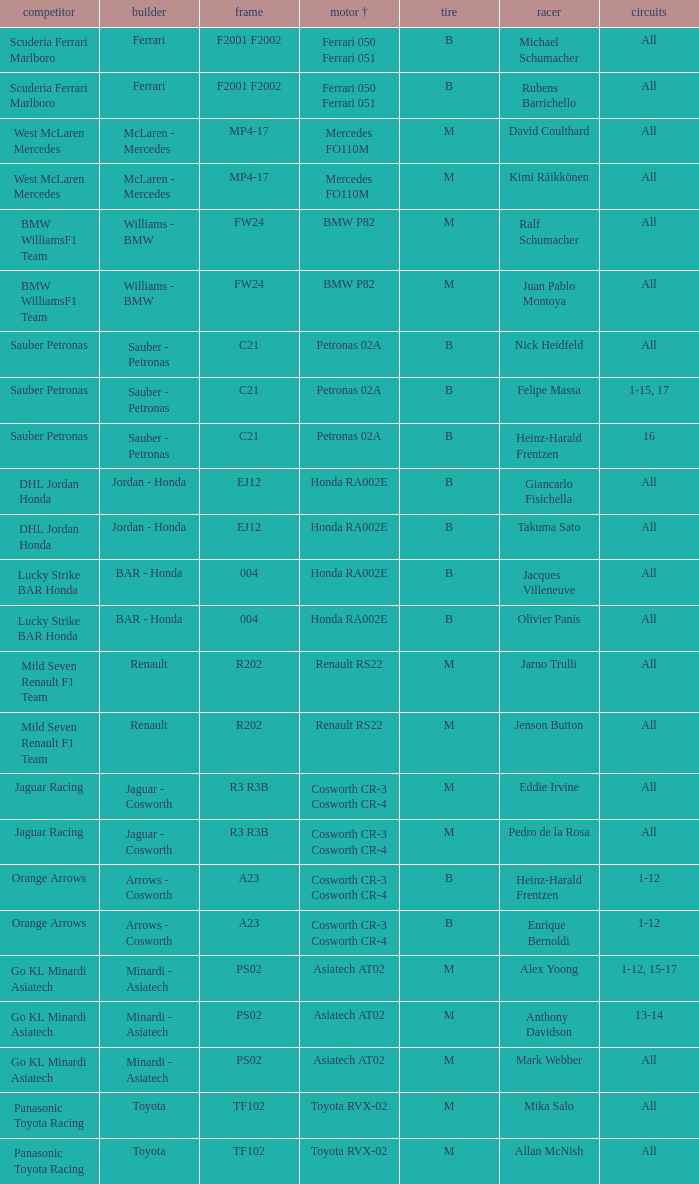What is the rounds when the engine is mercedes fo110m? All, All. 